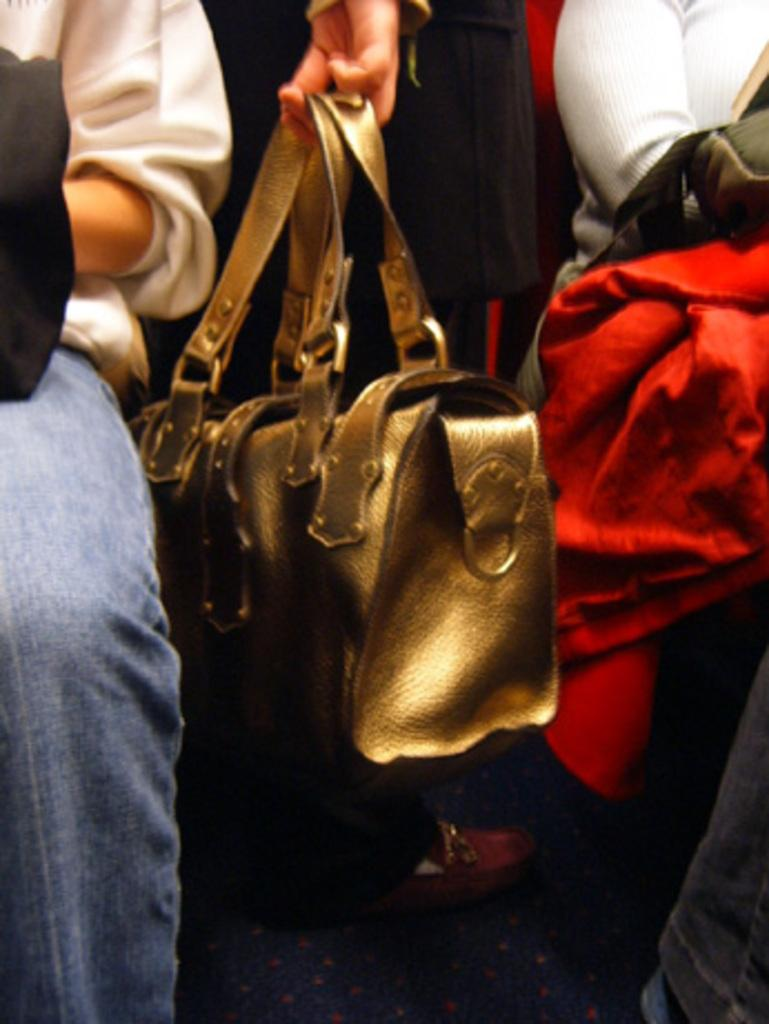Who is the main subject in the middle of the image? There is a woman in the middle of the image. What is the woman holding in the image? The woman is holding a bag. How many people are present in the image? There are three people in the image: the woman in the middle and two people on the sides. What is the person on the right side wearing? The person on the right side is wearing a red jacket. Does the person on the right side also have a bag? Yes, the person on the right side also has a bag. Where is the kettle located in the image? There is no kettle present in the image. Is there a battle taking place in the image? No, there is no battle depicted in the image. 